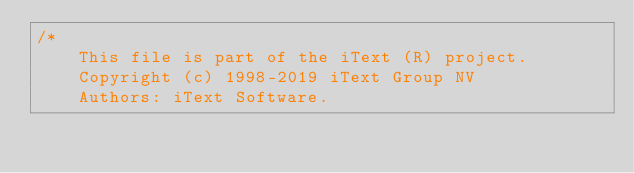<code> <loc_0><loc_0><loc_500><loc_500><_C#_>/*
    This file is part of the iText (R) project.
    Copyright (c) 1998-2019 iText Group NV
    Authors: iText Software.
</code> 